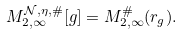Convert formula to latex. <formula><loc_0><loc_0><loc_500><loc_500>M _ { 2 , \infty } ^ { \mathcal { N } , \eta , \# } [ g ] = M _ { 2 , \infty } ^ { \# } ( r _ { g } ) .</formula> 